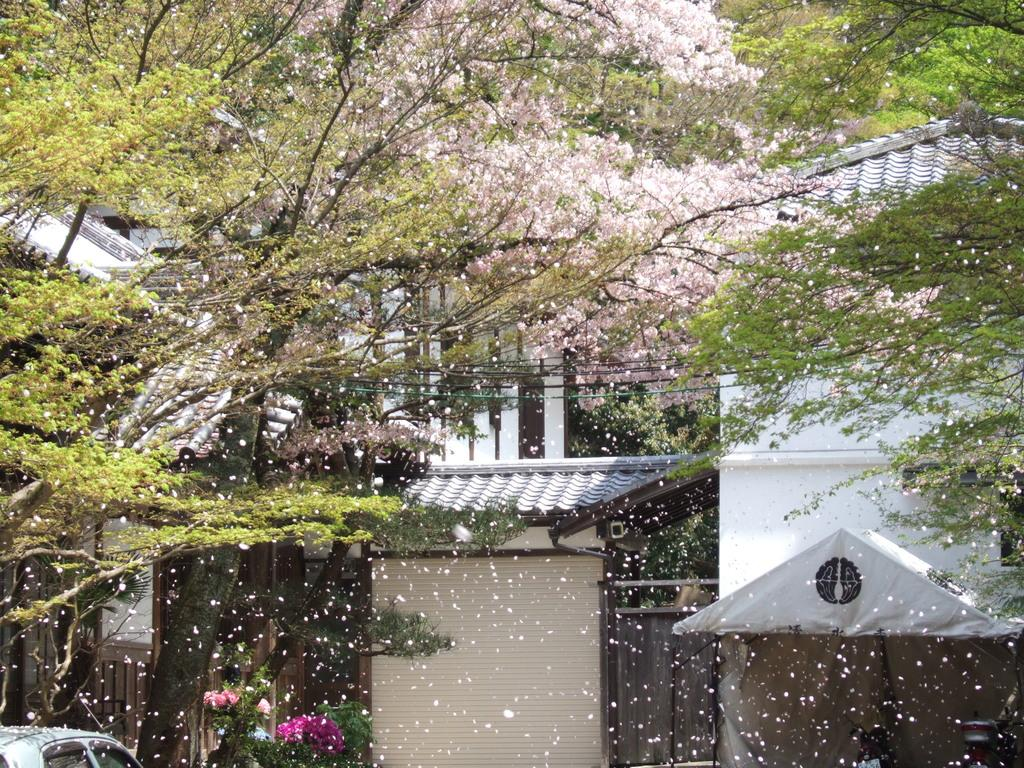What type of vegetation can be seen in the image? There are trees in the image. What other natural elements are present in the image? There are flowers in the image. What man-made object can be seen in the image? There is a vehicle in the image. What type of structure is visible in the image? There is a building in the image. What type of pancake is being measured in the image? There is no pancake present in the image, and therefore no measuring can be observed. 